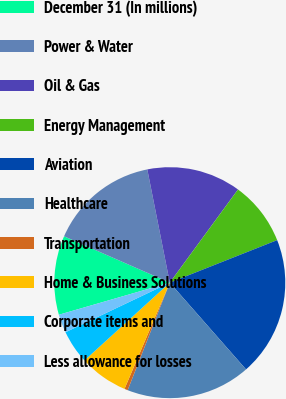<chart> <loc_0><loc_0><loc_500><loc_500><pie_chart><fcel>December 31 (In millions)<fcel>Power & Water<fcel>Oil & Gas<fcel>Energy Management<fcel>Aviation<fcel>Healthcare<fcel>Transportation<fcel>Home & Business Solutions<fcel>Corporate items and<fcel>Less allowance for losses<nl><fcel>11.06%<fcel>15.3%<fcel>13.18%<fcel>8.94%<fcel>19.53%<fcel>17.42%<fcel>0.47%<fcel>6.82%<fcel>4.7%<fcel>2.58%<nl></chart> 